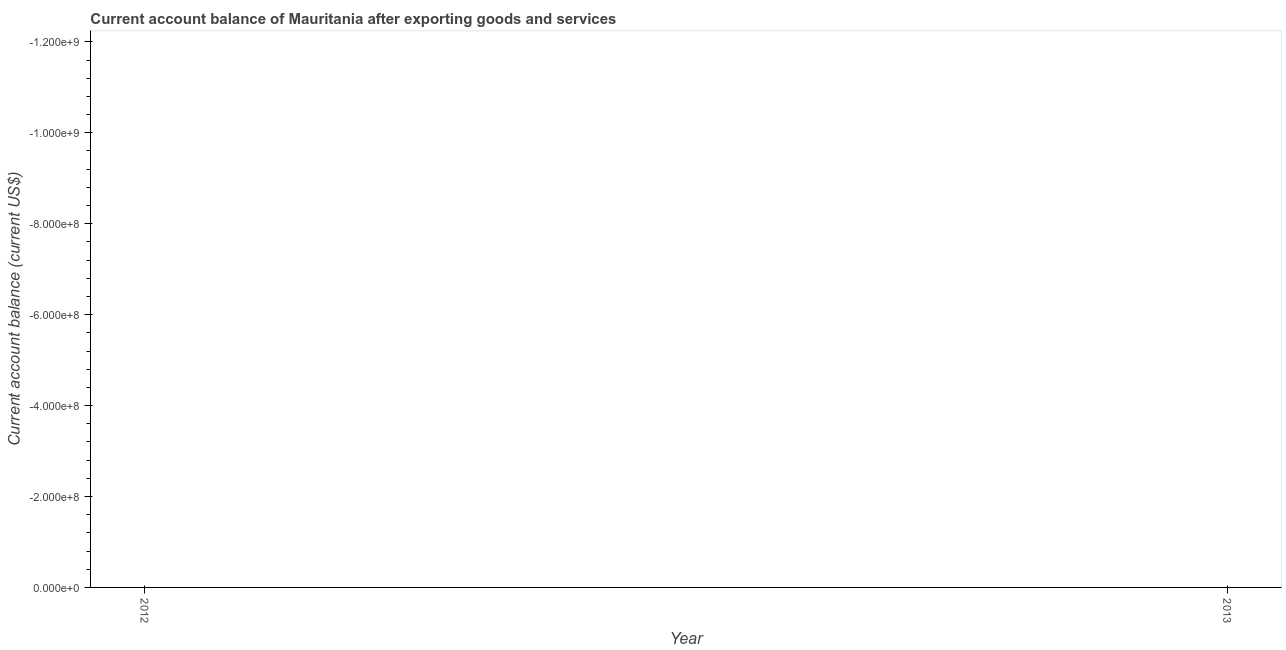What is the current account balance in 2013?
Offer a terse response. 0. Across all years, what is the minimum current account balance?
Provide a succinct answer. 0. In how many years, is the current account balance greater than -480000000 US$?
Make the answer very short. 0. In how many years, is the current account balance greater than the average current account balance taken over all years?
Provide a succinct answer. 0. Does the graph contain any zero values?
Ensure brevity in your answer.  Yes. Does the graph contain grids?
Your response must be concise. No. What is the title of the graph?
Your response must be concise. Current account balance of Mauritania after exporting goods and services. What is the label or title of the X-axis?
Offer a terse response. Year. What is the label or title of the Y-axis?
Offer a very short reply. Current account balance (current US$). What is the Current account balance (current US$) in 2012?
Offer a terse response. 0. What is the Current account balance (current US$) in 2013?
Offer a terse response. 0. 